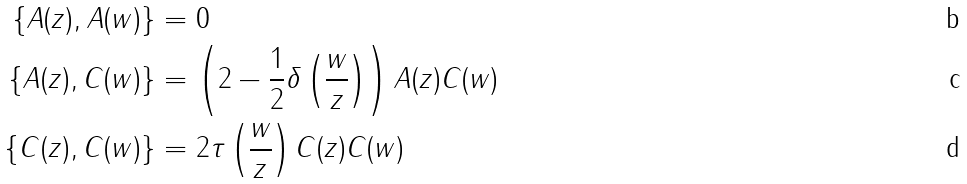Convert formula to latex. <formula><loc_0><loc_0><loc_500><loc_500>\{ A ( z ) , A ( w ) \} & = 0 \\ \{ A ( z ) , C ( w ) \} & = \left ( 2 - \frac { 1 } { 2 } \delta \left ( \frac { w } { z } \right ) \right ) A ( z ) C ( w ) \\ \{ C ( z ) , C ( w ) \} & = 2 \tau \left ( \frac { w } { z } \right ) C ( z ) C ( w )</formula> 